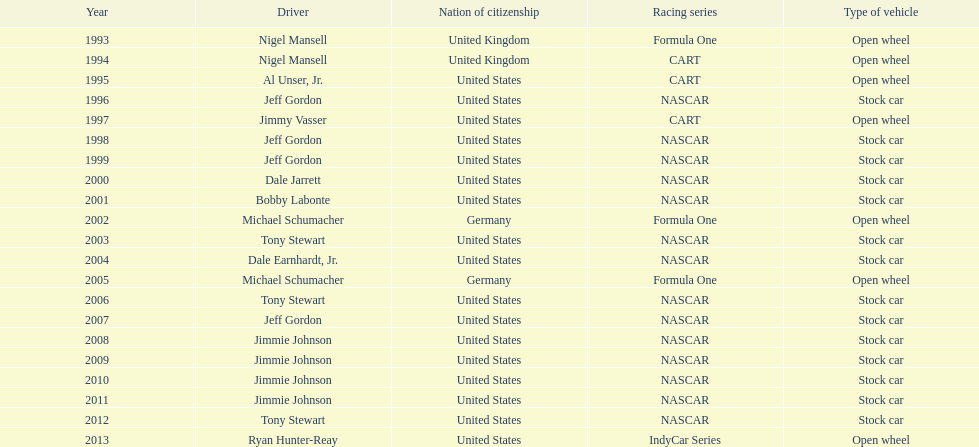Which driver won espy awards 11 years apart from each other? Jeff Gordon. 